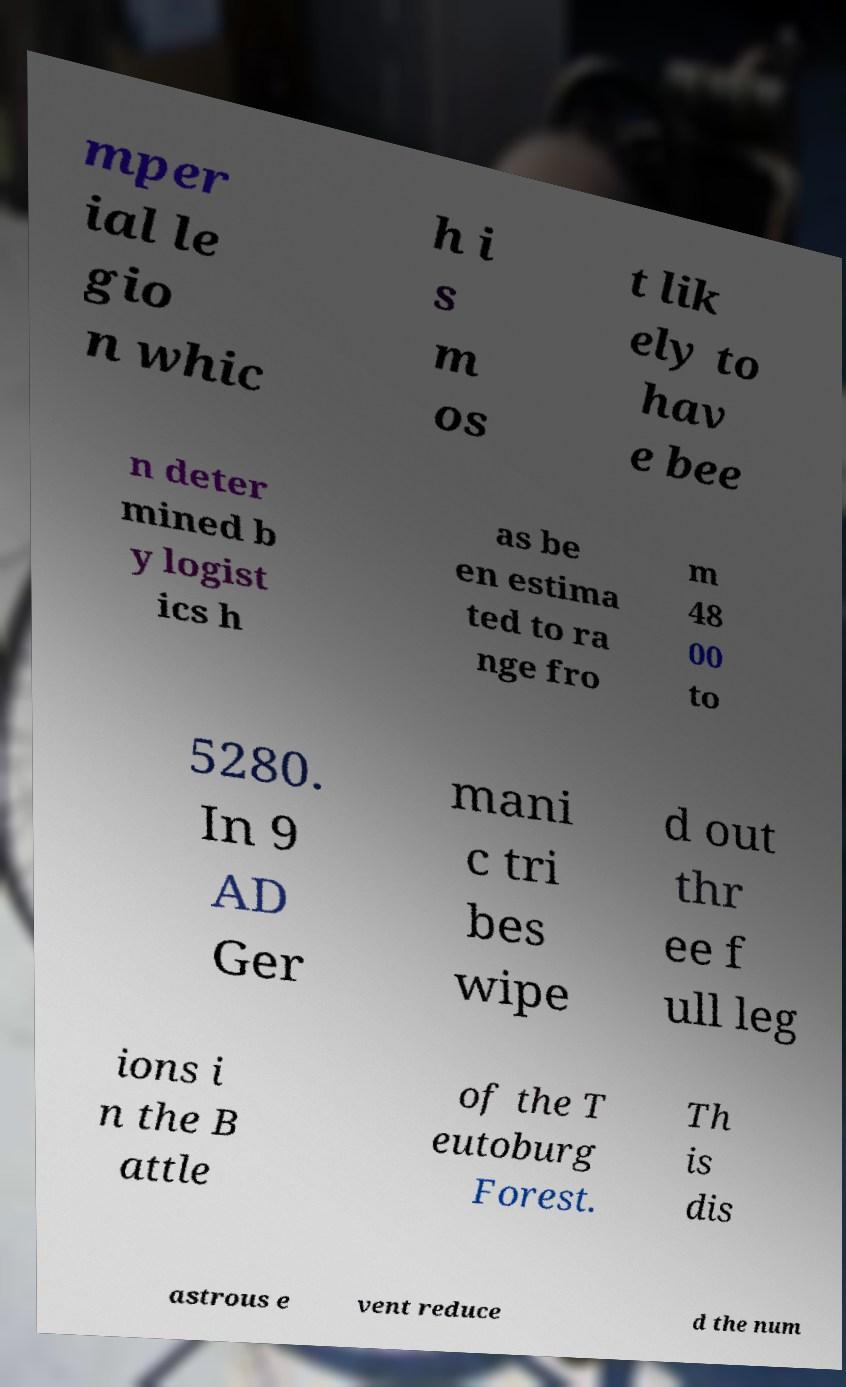Can you accurately transcribe the text from the provided image for me? mper ial le gio n whic h i s m os t lik ely to hav e bee n deter mined b y logist ics h as be en estima ted to ra nge fro m 48 00 to 5280. In 9 AD Ger mani c tri bes wipe d out thr ee f ull leg ions i n the B attle of the T eutoburg Forest. Th is dis astrous e vent reduce d the num 